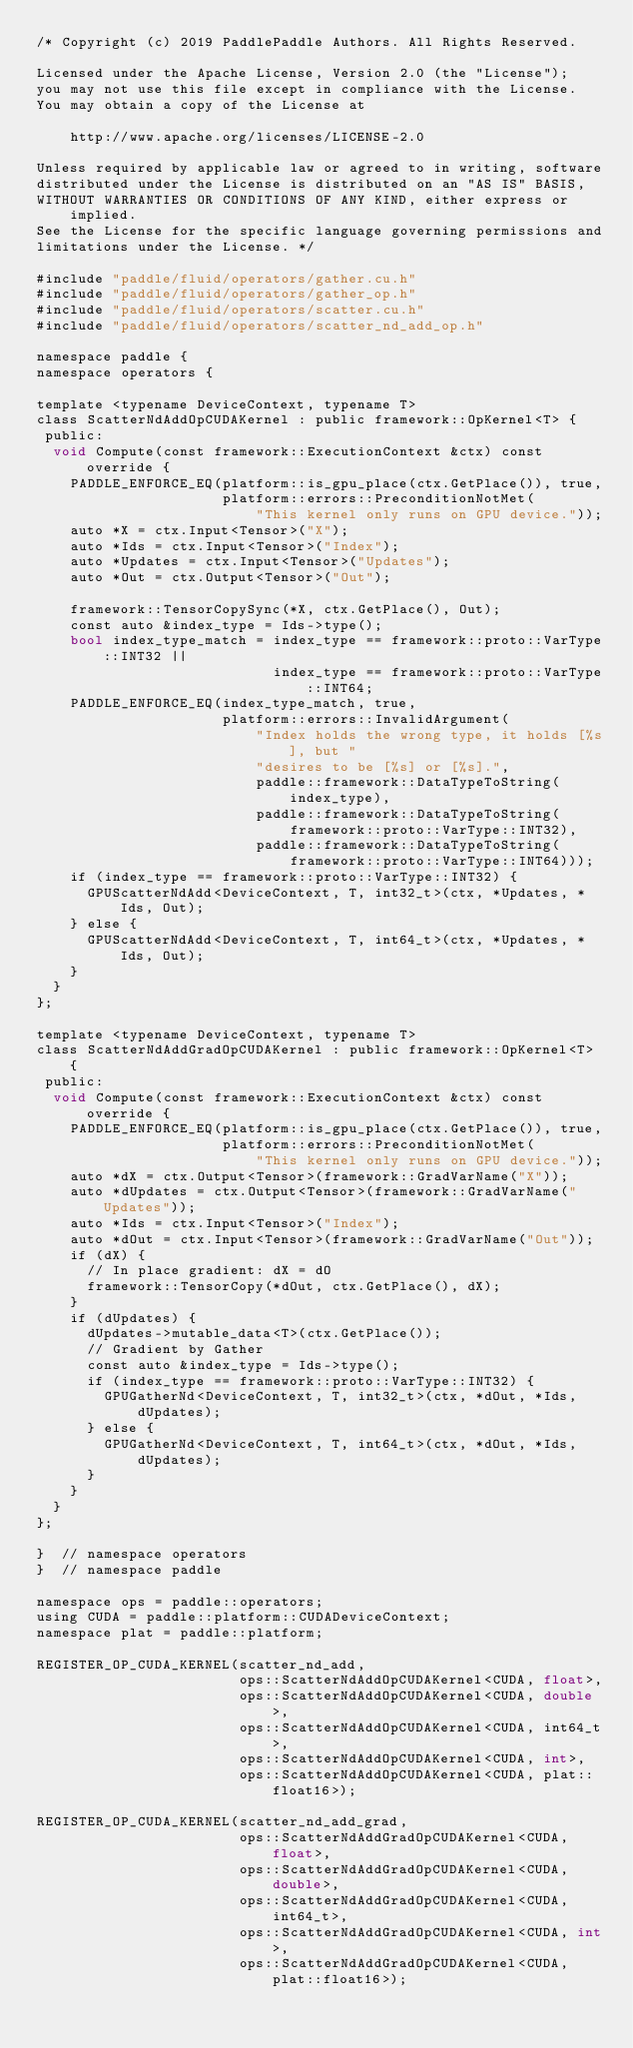Convert code to text. <code><loc_0><loc_0><loc_500><loc_500><_Cuda_>/* Copyright (c) 2019 PaddlePaddle Authors. All Rights Reserved.

Licensed under the Apache License, Version 2.0 (the "License");
you may not use this file except in compliance with the License.
You may obtain a copy of the License at

    http://www.apache.org/licenses/LICENSE-2.0

Unless required by applicable law or agreed to in writing, software
distributed under the License is distributed on an "AS IS" BASIS,
WITHOUT WARRANTIES OR CONDITIONS OF ANY KIND, either express or implied.
See the License for the specific language governing permissions and
limitations under the License. */

#include "paddle/fluid/operators/gather.cu.h"
#include "paddle/fluid/operators/gather_op.h"
#include "paddle/fluid/operators/scatter.cu.h"
#include "paddle/fluid/operators/scatter_nd_add_op.h"

namespace paddle {
namespace operators {

template <typename DeviceContext, typename T>
class ScatterNdAddOpCUDAKernel : public framework::OpKernel<T> {
 public:
  void Compute(const framework::ExecutionContext &ctx) const override {
    PADDLE_ENFORCE_EQ(platform::is_gpu_place(ctx.GetPlace()), true,
                      platform::errors::PreconditionNotMet(
                          "This kernel only runs on GPU device."));
    auto *X = ctx.Input<Tensor>("X");
    auto *Ids = ctx.Input<Tensor>("Index");
    auto *Updates = ctx.Input<Tensor>("Updates");
    auto *Out = ctx.Output<Tensor>("Out");

    framework::TensorCopySync(*X, ctx.GetPlace(), Out);
    const auto &index_type = Ids->type();
    bool index_type_match = index_type == framework::proto::VarType::INT32 ||
                            index_type == framework::proto::VarType::INT64;
    PADDLE_ENFORCE_EQ(index_type_match, true,
                      platform::errors::InvalidArgument(
                          "Index holds the wrong type, it holds [%s], but "
                          "desires to be [%s] or [%s].",
                          paddle::framework::DataTypeToString(index_type),
                          paddle::framework::DataTypeToString(
                              framework::proto::VarType::INT32),
                          paddle::framework::DataTypeToString(
                              framework::proto::VarType::INT64)));
    if (index_type == framework::proto::VarType::INT32) {
      GPUScatterNdAdd<DeviceContext, T, int32_t>(ctx, *Updates, *Ids, Out);
    } else {
      GPUScatterNdAdd<DeviceContext, T, int64_t>(ctx, *Updates, *Ids, Out);
    }
  }
};

template <typename DeviceContext, typename T>
class ScatterNdAddGradOpCUDAKernel : public framework::OpKernel<T> {
 public:
  void Compute(const framework::ExecutionContext &ctx) const override {
    PADDLE_ENFORCE_EQ(platform::is_gpu_place(ctx.GetPlace()), true,
                      platform::errors::PreconditionNotMet(
                          "This kernel only runs on GPU device."));
    auto *dX = ctx.Output<Tensor>(framework::GradVarName("X"));
    auto *dUpdates = ctx.Output<Tensor>(framework::GradVarName("Updates"));
    auto *Ids = ctx.Input<Tensor>("Index");
    auto *dOut = ctx.Input<Tensor>(framework::GradVarName("Out"));
    if (dX) {
      // In place gradient: dX = dO
      framework::TensorCopy(*dOut, ctx.GetPlace(), dX);
    }
    if (dUpdates) {
      dUpdates->mutable_data<T>(ctx.GetPlace());
      // Gradient by Gather
      const auto &index_type = Ids->type();
      if (index_type == framework::proto::VarType::INT32) {
        GPUGatherNd<DeviceContext, T, int32_t>(ctx, *dOut, *Ids, dUpdates);
      } else {
        GPUGatherNd<DeviceContext, T, int64_t>(ctx, *dOut, *Ids, dUpdates);
      }
    }
  }
};

}  // namespace operators
}  // namespace paddle

namespace ops = paddle::operators;
using CUDA = paddle::platform::CUDADeviceContext;
namespace plat = paddle::platform;

REGISTER_OP_CUDA_KERNEL(scatter_nd_add,
                        ops::ScatterNdAddOpCUDAKernel<CUDA, float>,
                        ops::ScatterNdAddOpCUDAKernel<CUDA, double>,
                        ops::ScatterNdAddOpCUDAKernel<CUDA, int64_t>,
                        ops::ScatterNdAddOpCUDAKernel<CUDA, int>,
                        ops::ScatterNdAddOpCUDAKernel<CUDA, plat::float16>);

REGISTER_OP_CUDA_KERNEL(scatter_nd_add_grad,
                        ops::ScatterNdAddGradOpCUDAKernel<CUDA, float>,
                        ops::ScatterNdAddGradOpCUDAKernel<CUDA, double>,
                        ops::ScatterNdAddGradOpCUDAKernel<CUDA, int64_t>,
                        ops::ScatterNdAddGradOpCUDAKernel<CUDA, int>,
                        ops::ScatterNdAddGradOpCUDAKernel<CUDA, plat::float16>);
</code> 